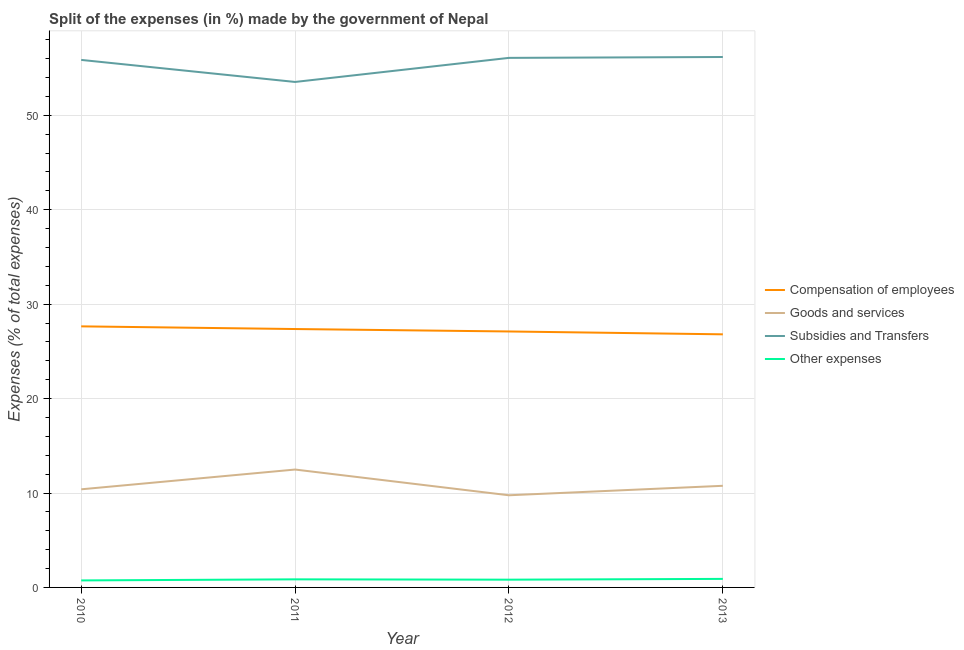Does the line corresponding to percentage of amount spent on compensation of employees intersect with the line corresponding to percentage of amount spent on other expenses?
Provide a succinct answer. No. What is the percentage of amount spent on other expenses in 2011?
Give a very brief answer. 0.86. Across all years, what is the maximum percentage of amount spent on other expenses?
Offer a terse response. 0.9. Across all years, what is the minimum percentage of amount spent on other expenses?
Make the answer very short. 0.74. What is the total percentage of amount spent on other expenses in the graph?
Provide a short and direct response. 3.32. What is the difference between the percentage of amount spent on other expenses in 2010 and that in 2013?
Ensure brevity in your answer.  -0.16. What is the difference between the percentage of amount spent on subsidies in 2012 and the percentage of amount spent on goods and services in 2010?
Give a very brief answer. 45.69. What is the average percentage of amount spent on other expenses per year?
Provide a succinct answer. 0.83. In the year 2010, what is the difference between the percentage of amount spent on other expenses and percentage of amount spent on compensation of employees?
Provide a succinct answer. -26.91. What is the ratio of the percentage of amount spent on goods and services in 2011 to that in 2013?
Offer a very short reply. 1.16. What is the difference between the highest and the second highest percentage of amount spent on other expenses?
Offer a terse response. 0.05. What is the difference between the highest and the lowest percentage of amount spent on compensation of employees?
Keep it short and to the point. 0.84. In how many years, is the percentage of amount spent on subsidies greater than the average percentage of amount spent on subsidies taken over all years?
Your answer should be compact. 3. Is it the case that in every year, the sum of the percentage of amount spent on compensation of employees and percentage of amount spent on goods and services is greater than the percentage of amount spent on subsidies?
Give a very brief answer. No. Does the percentage of amount spent on other expenses monotonically increase over the years?
Keep it short and to the point. No. Is the percentage of amount spent on goods and services strictly less than the percentage of amount spent on compensation of employees over the years?
Keep it short and to the point. Yes. How many years are there in the graph?
Your answer should be very brief. 4. What is the difference between two consecutive major ticks on the Y-axis?
Keep it short and to the point. 10. Are the values on the major ticks of Y-axis written in scientific E-notation?
Make the answer very short. No. Does the graph contain grids?
Provide a short and direct response. Yes. How are the legend labels stacked?
Ensure brevity in your answer.  Vertical. What is the title of the graph?
Make the answer very short. Split of the expenses (in %) made by the government of Nepal. What is the label or title of the Y-axis?
Ensure brevity in your answer.  Expenses (% of total expenses). What is the Expenses (% of total expenses) of Compensation of employees in 2010?
Give a very brief answer. 27.65. What is the Expenses (% of total expenses) in Goods and services in 2010?
Offer a very short reply. 10.39. What is the Expenses (% of total expenses) in Subsidies and Transfers in 2010?
Offer a terse response. 55.87. What is the Expenses (% of total expenses) in Other expenses in 2010?
Ensure brevity in your answer.  0.74. What is the Expenses (% of total expenses) in Compensation of employees in 2011?
Ensure brevity in your answer.  27.37. What is the Expenses (% of total expenses) in Goods and services in 2011?
Offer a terse response. 12.49. What is the Expenses (% of total expenses) in Subsidies and Transfers in 2011?
Your answer should be very brief. 53.53. What is the Expenses (% of total expenses) of Other expenses in 2011?
Keep it short and to the point. 0.86. What is the Expenses (% of total expenses) in Compensation of employees in 2012?
Ensure brevity in your answer.  27.11. What is the Expenses (% of total expenses) in Goods and services in 2012?
Your answer should be compact. 9.76. What is the Expenses (% of total expenses) of Subsidies and Transfers in 2012?
Ensure brevity in your answer.  56.08. What is the Expenses (% of total expenses) in Other expenses in 2012?
Keep it short and to the point. 0.82. What is the Expenses (% of total expenses) of Compensation of employees in 2013?
Offer a very short reply. 26.8. What is the Expenses (% of total expenses) in Goods and services in 2013?
Your response must be concise. 10.76. What is the Expenses (% of total expenses) in Subsidies and Transfers in 2013?
Provide a succinct answer. 56.17. What is the Expenses (% of total expenses) in Other expenses in 2013?
Offer a very short reply. 0.9. Across all years, what is the maximum Expenses (% of total expenses) in Compensation of employees?
Offer a terse response. 27.65. Across all years, what is the maximum Expenses (% of total expenses) of Goods and services?
Offer a very short reply. 12.49. Across all years, what is the maximum Expenses (% of total expenses) in Subsidies and Transfers?
Your answer should be very brief. 56.17. Across all years, what is the maximum Expenses (% of total expenses) of Other expenses?
Make the answer very short. 0.9. Across all years, what is the minimum Expenses (% of total expenses) in Compensation of employees?
Provide a succinct answer. 26.8. Across all years, what is the minimum Expenses (% of total expenses) of Goods and services?
Your answer should be very brief. 9.76. Across all years, what is the minimum Expenses (% of total expenses) of Subsidies and Transfers?
Your response must be concise. 53.53. Across all years, what is the minimum Expenses (% of total expenses) in Other expenses?
Provide a short and direct response. 0.74. What is the total Expenses (% of total expenses) of Compensation of employees in the graph?
Keep it short and to the point. 108.92. What is the total Expenses (% of total expenses) in Goods and services in the graph?
Give a very brief answer. 43.4. What is the total Expenses (% of total expenses) in Subsidies and Transfers in the graph?
Make the answer very short. 221.65. What is the total Expenses (% of total expenses) in Other expenses in the graph?
Offer a terse response. 3.32. What is the difference between the Expenses (% of total expenses) in Compensation of employees in 2010 and that in 2011?
Provide a succinct answer. 0.28. What is the difference between the Expenses (% of total expenses) of Goods and services in 2010 and that in 2011?
Provide a short and direct response. -2.09. What is the difference between the Expenses (% of total expenses) in Subsidies and Transfers in 2010 and that in 2011?
Your answer should be very brief. 2.33. What is the difference between the Expenses (% of total expenses) of Other expenses in 2010 and that in 2011?
Your answer should be very brief. -0.11. What is the difference between the Expenses (% of total expenses) of Compensation of employees in 2010 and that in 2012?
Ensure brevity in your answer.  0.54. What is the difference between the Expenses (% of total expenses) in Goods and services in 2010 and that in 2012?
Offer a very short reply. 0.63. What is the difference between the Expenses (% of total expenses) of Subsidies and Transfers in 2010 and that in 2012?
Your response must be concise. -0.22. What is the difference between the Expenses (% of total expenses) of Other expenses in 2010 and that in 2012?
Make the answer very short. -0.08. What is the difference between the Expenses (% of total expenses) of Compensation of employees in 2010 and that in 2013?
Make the answer very short. 0.84. What is the difference between the Expenses (% of total expenses) in Goods and services in 2010 and that in 2013?
Offer a terse response. -0.37. What is the difference between the Expenses (% of total expenses) of Subsidies and Transfers in 2010 and that in 2013?
Make the answer very short. -0.31. What is the difference between the Expenses (% of total expenses) in Other expenses in 2010 and that in 2013?
Make the answer very short. -0.16. What is the difference between the Expenses (% of total expenses) in Compensation of employees in 2011 and that in 2012?
Your answer should be compact. 0.26. What is the difference between the Expenses (% of total expenses) in Goods and services in 2011 and that in 2012?
Keep it short and to the point. 2.73. What is the difference between the Expenses (% of total expenses) of Subsidies and Transfers in 2011 and that in 2012?
Offer a very short reply. -2.55. What is the difference between the Expenses (% of total expenses) in Other expenses in 2011 and that in 2012?
Offer a terse response. 0.04. What is the difference between the Expenses (% of total expenses) of Compensation of employees in 2011 and that in 2013?
Keep it short and to the point. 0.56. What is the difference between the Expenses (% of total expenses) in Goods and services in 2011 and that in 2013?
Provide a succinct answer. 1.72. What is the difference between the Expenses (% of total expenses) in Subsidies and Transfers in 2011 and that in 2013?
Give a very brief answer. -2.64. What is the difference between the Expenses (% of total expenses) in Other expenses in 2011 and that in 2013?
Keep it short and to the point. -0.05. What is the difference between the Expenses (% of total expenses) in Compensation of employees in 2012 and that in 2013?
Give a very brief answer. 0.3. What is the difference between the Expenses (% of total expenses) of Goods and services in 2012 and that in 2013?
Provide a short and direct response. -1. What is the difference between the Expenses (% of total expenses) of Subsidies and Transfers in 2012 and that in 2013?
Offer a terse response. -0.09. What is the difference between the Expenses (% of total expenses) of Other expenses in 2012 and that in 2013?
Your answer should be very brief. -0.08. What is the difference between the Expenses (% of total expenses) of Compensation of employees in 2010 and the Expenses (% of total expenses) of Goods and services in 2011?
Give a very brief answer. 15.16. What is the difference between the Expenses (% of total expenses) in Compensation of employees in 2010 and the Expenses (% of total expenses) in Subsidies and Transfers in 2011?
Your answer should be compact. -25.88. What is the difference between the Expenses (% of total expenses) of Compensation of employees in 2010 and the Expenses (% of total expenses) of Other expenses in 2011?
Provide a succinct answer. 26.79. What is the difference between the Expenses (% of total expenses) of Goods and services in 2010 and the Expenses (% of total expenses) of Subsidies and Transfers in 2011?
Your answer should be compact. -43.14. What is the difference between the Expenses (% of total expenses) of Goods and services in 2010 and the Expenses (% of total expenses) of Other expenses in 2011?
Ensure brevity in your answer.  9.54. What is the difference between the Expenses (% of total expenses) in Subsidies and Transfers in 2010 and the Expenses (% of total expenses) in Other expenses in 2011?
Provide a succinct answer. 55.01. What is the difference between the Expenses (% of total expenses) of Compensation of employees in 2010 and the Expenses (% of total expenses) of Goods and services in 2012?
Provide a short and direct response. 17.89. What is the difference between the Expenses (% of total expenses) of Compensation of employees in 2010 and the Expenses (% of total expenses) of Subsidies and Transfers in 2012?
Give a very brief answer. -28.43. What is the difference between the Expenses (% of total expenses) in Compensation of employees in 2010 and the Expenses (% of total expenses) in Other expenses in 2012?
Offer a terse response. 26.83. What is the difference between the Expenses (% of total expenses) in Goods and services in 2010 and the Expenses (% of total expenses) in Subsidies and Transfers in 2012?
Keep it short and to the point. -45.69. What is the difference between the Expenses (% of total expenses) in Goods and services in 2010 and the Expenses (% of total expenses) in Other expenses in 2012?
Provide a short and direct response. 9.57. What is the difference between the Expenses (% of total expenses) of Subsidies and Transfers in 2010 and the Expenses (% of total expenses) of Other expenses in 2012?
Give a very brief answer. 55.05. What is the difference between the Expenses (% of total expenses) of Compensation of employees in 2010 and the Expenses (% of total expenses) of Goods and services in 2013?
Give a very brief answer. 16.88. What is the difference between the Expenses (% of total expenses) in Compensation of employees in 2010 and the Expenses (% of total expenses) in Subsidies and Transfers in 2013?
Provide a succinct answer. -28.53. What is the difference between the Expenses (% of total expenses) of Compensation of employees in 2010 and the Expenses (% of total expenses) of Other expenses in 2013?
Provide a succinct answer. 26.74. What is the difference between the Expenses (% of total expenses) of Goods and services in 2010 and the Expenses (% of total expenses) of Subsidies and Transfers in 2013?
Your answer should be very brief. -45.78. What is the difference between the Expenses (% of total expenses) in Goods and services in 2010 and the Expenses (% of total expenses) in Other expenses in 2013?
Ensure brevity in your answer.  9.49. What is the difference between the Expenses (% of total expenses) of Subsidies and Transfers in 2010 and the Expenses (% of total expenses) of Other expenses in 2013?
Make the answer very short. 54.96. What is the difference between the Expenses (% of total expenses) of Compensation of employees in 2011 and the Expenses (% of total expenses) of Goods and services in 2012?
Your response must be concise. 17.61. What is the difference between the Expenses (% of total expenses) of Compensation of employees in 2011 and the Expenses (% of total expenses) of Subsidies and Transfers in 2012?
Offer a very short reply. -28.72. What is the difference between the Expenses (% of total expenses) of Compensation of employees in 2011 and the Expenses (% of total expenses) of Other expenses in 2012?
Keep it short and to the point. 26.55. What is the difference between the Expenses (% of total expenses) of Goods and services in 2011 and the Expenses (% of total expenses) of Subsidies and Transfers in 2012?
Your answer should be compact. -43.6. What is the difference between the Expenses (% of total expenses) of Goods and services in 2011 and the Expenses (% of total expenses) of Other expenses in 2012?
Your answer should be very brief. 11.66. What is the difference between the Expenses (% of total expenses) in Subsidies and Transfers in 2011 and the Expenses (% of total expenses) in Other expenses in 2012?
Give a very brief answer. 52.71. What is the difference between the Expenses (% of total expenses) in Compensation of employees in 2011 and the Expenses (% of total expenses) in Goods and services in 2013?
Keep it short and to the point. 16.6. What is the difference between the Expenses (% of total expenses) of Compensation of employees in 2011 and the Expenses (% of total expenses) of Subsidies and Transfers in 2013?
Your answer should be very brief. -28.81. What is the difference between the Expenses (% of total expenses) in Compensation of employees in 2011 and the Expenses (% of total expenses) in Other expenses in 2013?
Provide a short and direct response. 26.46. What is the difference between the Expenses (% of total expenses) of Goods and services in 2011 and the Expenses (% of total expenses) of Subsidies and Transfers in 2013?
Keep it short and to the point. -43.69. What is the difference between the Expenses (% of total expenses) in Goods and services in 2011 and the Expenses (% of total expenses) in Other expenses in 2013?
Provide a succinct answer. 11.58. What is the difference between the Expenses (% of total expenses) of Subsidies and Transfers in 2011 and the Expenses (% of total expenses) of Other expenses in 2013?
Your answer should be compact. 52.63. What is the difference between the Expenses (% of total expenses) of Compensation of employees in 2012 and the Expenses (% of total expenses) of Goods and services in 2013?
Your answer should be very brief. 16.34. What is the difference between the Expenses (% of total expenses) in Compensation of employees in 2012 and the Expenses (% of total expenses) in Subsidies and Transfers in 2013?
Make the answer very short. -29.07. What is the difference between the Expenses (% of total expenses) in Compensation of employees in 2012 and the Expenses (% of total expenses) in Other expenses in 2013?
Give a very brief answer. 26.2. What is the difference between the Expenses (% of total expenses) of Goods and services in 2012 and the Expenses (% of total expenses) of Subsidies and Transfers in 2013?
Offer a very short reply. -46.41. What is the difference between the Expenses (% of total expenses) of Goods and services in 2012 and the Expenses (% of total expenses) of Other expenses in 2013?
Offer a very short reply. 8.86. What is the difference between the Expenses (% of total expenses) of Subsidies and Transfers in 2012 and the Expenses (% of total expenses) of Other expenses in 2013?
Your answer should be compact. 55.18. What is the average Expenses (% of total expenses) in Compensation of employees per year?
Offer a very short reply. 27.23. What is the average Expenses (% of total expenses) of Goods and services per year?
Your answer should be compact. 10.85. What is the average Expenses (% of total expenses) of Subsidies and Transfers per year?
Ensure brevity in your answer.  55.41. What is the average Expenses (% of total expenses) of Other expenses per year?
Give a very brief answer. 0.83. In the year 2010, what is the difference between the Expenses (% of total expenses) of Compensation of employees and Expenses (% of total expenses) of Goods and services?
Your answer should be very brief. 17.26. In the year 2010, what is the difference between the Expenses (% of total expenses) in Compensation of employees and Expenses (% of total expenses) in Subsidies and Transfers?
Your response must be concise. -28.22. In the year 2010, what is the difference between the Expenses (% of total expenses) in Compensation of employees and Expenses (% of total expenses) in Other expenses?
Provide a succinct answer. 26.91. In the year 2010, what is the difference between the Expenses (% of total expenses) of Goods and services and Expenses (% of total expenses) of Subsidies and Transfers?
Your answer should be very brief. -45.47. In the year 2010, what is the difference between the Expenses (% of total expenses) of Goods and services and Expenses (% of total expenses) of Other expenses?
Keep it short and to the point. 9.65. In the year 2010, what is the difference between the Expenses (% of total expenses) in Subsidies and Transfers and Expenses (% of total expenses) in Other expenses?
Your answer should be very brief. 55.12. In the year 2011, what is the difference between the Expenses (% of total expenses) of Compensation of employees and Expenses (% of total expenses) of Goods and services?
Your answer should be very brief. 14.88. In the year 2011, what is the difference between the Expenses (% of total expenses) of Compensation of employees and Expenses (% of total expenses) of Subsidies and Transfers?
Offer a very short reply. -26.17. In the year 2011, what is the difference between the Expenses (% of total expenses) of Compensation of employees and Expenses (% of total expenses) of Other expenses?
Keep it short and to the point. 26.51. In the year 2011, what is the difference between the Expenses (% of total expenses) of Goods and services and Expenses (% of total expenses) of Subsidies and Transfers?
Make the answer very short. -41.05. In the year 2011, what is the difference between the Expenses (% of total expenses) in Goods and services and Expenses (% of total expenses) in Other expenses?
Provide a succinct answer. 11.63. In the year 2011, what is the difference between the Expenses (% of total expenses) in Subsidies and Transfers and Expenses (% of total expenses) in Other expenses?
Your answer should be very brief. 52.68. In the year 2012, what is the difference between the Expenses (% of total expenses) in Compensation of employees and Expenses (% of total expenses) in Goods and services?
Provide a succinct answer. 17.35. In the year 2012, what is the difference between the Expenses (% of total expenses) in Compensation of employees and Expenses (% of total expenses) in Subsidies and Transfers?
Your answer should be very brief. -28.97. In the year 2012, what is the difference between the Expenses (% of total expenses) of Compensation of employees and Expenses (% of total expenses) of Other expenses?
Offer a very short reply. 26.29. In the year 2012, what is the difference between the Expenses (% of total expenses) of Goods and services and Expenses (% of total expenses) of Subsidies and Transfers?
Provide a short and direct response. -46.32. In the year 2012, what is the difference between the Expenses (% of total expenses) in Goods and services and Expenses (% of total expenses) in Other expenses?
Give a very brief answer. 8.94. In the year 2012, what is the difference between the Expenses (% of total expenses) of Subsidies and Transfers and Expenses (% of total expenses) of Other expenses?
Offer a terse response. 55.26. In the year 2013, what is the difference between the Expenses (% of total expenses) in Compensation of employees and Expenses (% of total expenses) in Goods and services?
Keep it short and to the point. 16.04. In the year 2013, what is the difference between the Expenses (% of total expenses) in Compensation of employees and Expenses (% of total expenses) in Subsidies and Transfers?
Make the answer very short. -29.37. In the year 2013, what is the difference between the Expenses (% of total expenses) in Compensation of employees and Expenses (% of total expenses) in Other expenses?
Your answer should be very brief. 25.9. In the year 2013, what is the difference between the Expenses (% of total expenses) in Goods and services and Expenses (% of total expenses) in Subsidies and Transfers?
Keep it short and to the point. -45.41. In the year 2013, what is the difference between the Expenses (% of total expenses) of Goods and services and Expenses (% of total expenses) of Other expenses?
Keep it short and to the point. 9.86. In the year 2013, what is the difference between the Expenses (% of total expenses) in Subsidies and Transfers and Expenses (% of total expenses) in Other expenses?
Keep it short and to the point. 55.27. What is the ratio of the Expenses (% of total expenses) in Compensation of employees in 2010 to that in 2011?
Give a very brief answer. 1.01. What is the ratio of the Expenses (% of total expenses) of Goods and services in 2010 to that in 2011?
Your answer should be very brief. 0.83. What is the ratio of the Expenses (% of total expenses) of Subsidies and Transfers in 2010 to that in 2011?
Your answer should be very brief. 1.04. What is the ratio of the Expenses (% of total expenses) in Other expenses in 2010 to that in 2011?
Offer a terse response. 0.87. What is the ratio of the Expenses (% of total expenses) in Compensation of employees in 2010 to that in 2012?
Your answer should be compact. 1.02. What is the ratio of the Expenses (% of total expenses) in Goods and services in 2010 to that in 2012?
Make the answer very short. 1.06. What is the ratio of the Expenses (% of total expenses) in Other expenses in 2010 to that in 2012?
Keep it short and to the point. 0.9. What is the ratio of the Expenses (% of total expenses) in Compensation of employees in 2010 to that in 2013?
Offer a terse response. 1.03. What is the ratio of the Expenses (% of total expenses) in Goods and services in 2010 to that in 2013?
Make the answer very short. 0.97. What is the ratio of the Expenses (% of total expenses) of Other expenses in 2010 to that in 2013?
Make the answer very short. 0.82. What is the ratio of the Expenses (% of total expenses) of Compensation of employees in 2011 to that in 2012?
Your answer should be very brief. 1.01. What is the ratio of the Expenses (% of total expenses) of Goods and services in 2011 to that in 2012?
Provide a short and direct response. 1.28. What is the ratio of the Expenses (% of total expenses) in Subsidies and Transfers in 2011 to that in 2012?
Offer a terse response. 0.95. What is the ratio of the Expenses (% of total expenses) of Other expenses in 2011 to that in 2012?
Offer a terse response. 1.04. What is the ratio of the Expenses (% of total expenses) of Compensation of employees in 2011 to that in 2013?
Offer a very short reply. 1.02. What is the ratio of the Expenses (% of total expenses) in Goods and services in 2011 to that in 2013?
Offer a very short reply. 1.16. What is the ratio of the Expenses (% of total expenses) of Subsidies and Transfers in 2011 to that in 2013?
Your answer should be compact. 0.95. What is the ratio of the Expenses (% of total expenses) in Other expenses in 2011 to that in 2013?
Keep it short and to the point. 0.95. What is the ratio of the Expenses (% of total expenses) in Compensation of employees in 2012 to that in 2013?
Ensure brevity in your answer.  1.01. What is the ratio of the Expenses (% of total expenses) of Goods and services in 2012 to that in 2013?
Offer a very short reply. 0.91. What is the ratio of the Expenses (% of total expenses) in Other expenses in 2012 to that in 2013?
Give a very brief answer. 0.91. What is the difference between the highest and the second highest Expenses (% of total expenses) of Compensation of employees?
Offer a very short reply. 0.28. What is the difference between the highest and the second highest Expenses (% of total expenses) in Goods and services?
Your answer should be very brief. 1.72. What is the difference between the highest and the second highest Expenses (% of total expenses) of Subsidies and Transfers?
Offer a terse response. 0.09. What is the difference between the highest and the second highest Expenses (% of total expenses) of Other expenses?
Make the answer very short. 0.05. What is the difference between the highest and the lowest Expenses (% of total expenses) of Compensation of employees?
Your answer should be very brief. 0.84. What is the difference between the highest and the lowest Expenses (% of total expenses) of Goods and services?
Your answer should be compact. 2.73. What is the difference between the highest and the lowest Expenses (% of total expenses) of Subsidies and Transfers?
Your response must be concise. 2.64. What is the difference between the highest and the lowest Expenses (% of total expenses) in Other expenses?
Keep it short and to the point. 0.16. 